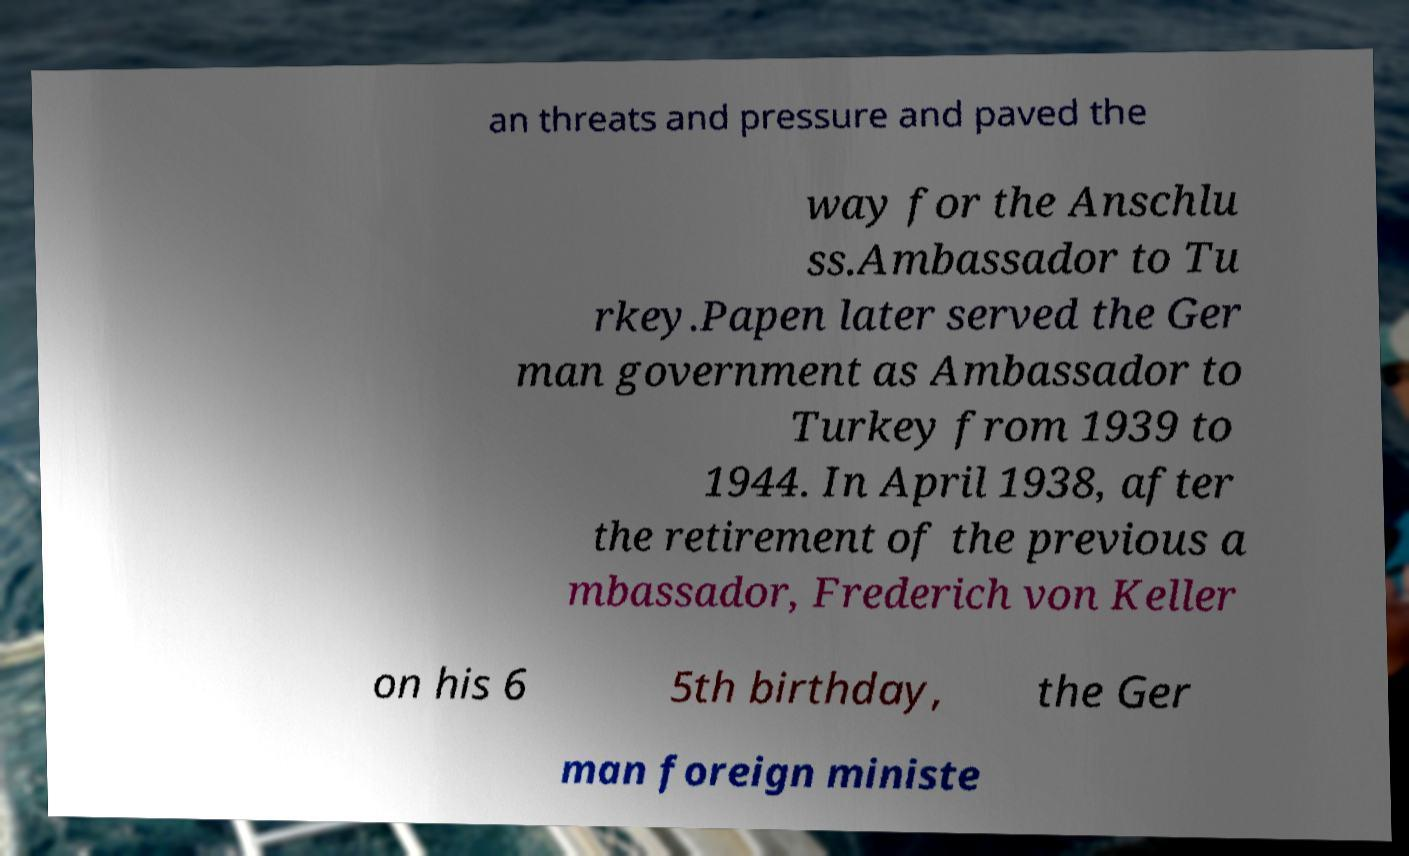I need the written content from this picture converted into text. Can you do that? an threats and pressure and paved the way for the Anschlu ss.Ambassador to Tu rkey.Papen later served the Ger man government as Ambassador to Turkey from 1939 to 1944. In April 1938, after the retirement of the previous a mbassador, Frederich von Keller on his 6 5th birthday, the Ger man foreign ministe 